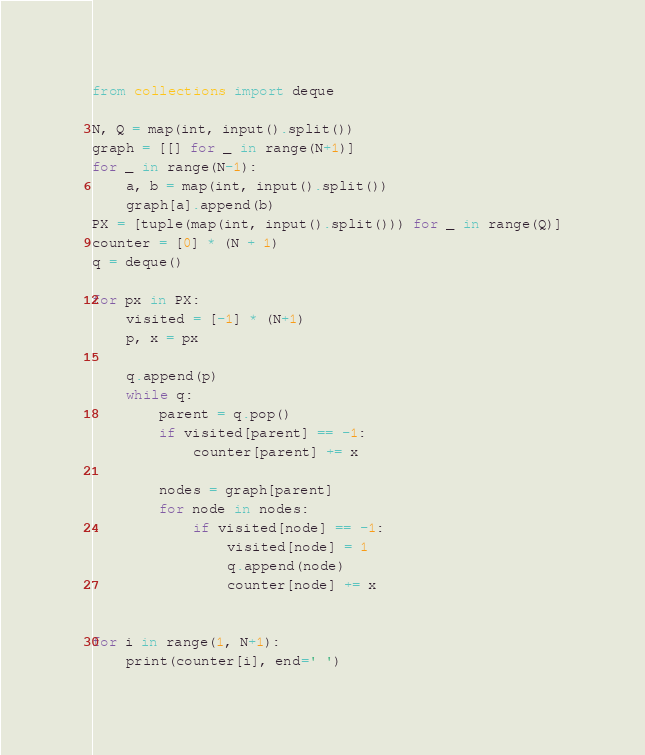<code> <loc_0><loc_0><loc_500><loc_500><_Python_>from collections import deque

N, Q = map(int, input().split())
graph = [[] for _ in range(N+1)]
for _ in range(N-1):
    a, b = map(int, input().split())
    graph[a].append(b)
PX = [tuple(map(int, input().split())) for _ in range(Q)]
counter = [0] * (N + 1)
q = deque()

for px in PX:
    visited = [-1] * (N+1)
    p, x = px

    q.append(p)
    while q:
        parent = q.pop()
        if visited[parent] == -1:
            counter[parent] += x

        nodes = graph[parent]
        for node in nodes:
            if visited[node] == -1:
                visited[node] = 1
                q.append(node)
                counter[node] += x


for i in range(1, N+1):
    print(counter[i], end=' ')

</code> 